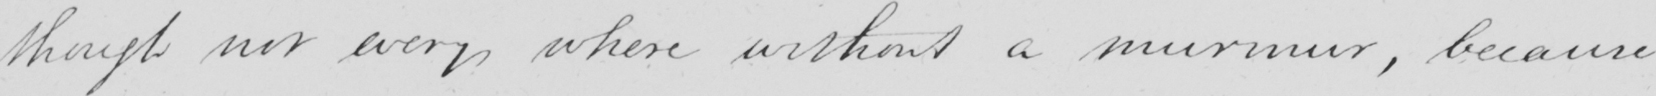What text is written in this handwritten line? though not every where without a murmur , because 